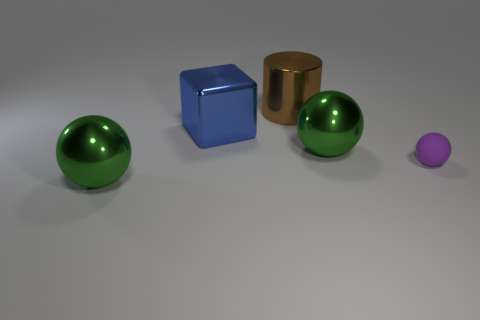Add 1 gray matte cubes. How many objects exist? 6 Subtract all spheres. How many objects are left? 2 Subtract all metallic spheres. Subtract all brown metallic cylinders. How many objects are left? 2 Add 1 big brown cylinders. How many big brown cylinders are left? 2 Add 5 big blue metal blocks. How many big blue metal blocks exist? 6 Subtract 1 purple spheres. How many objects are left? 4 